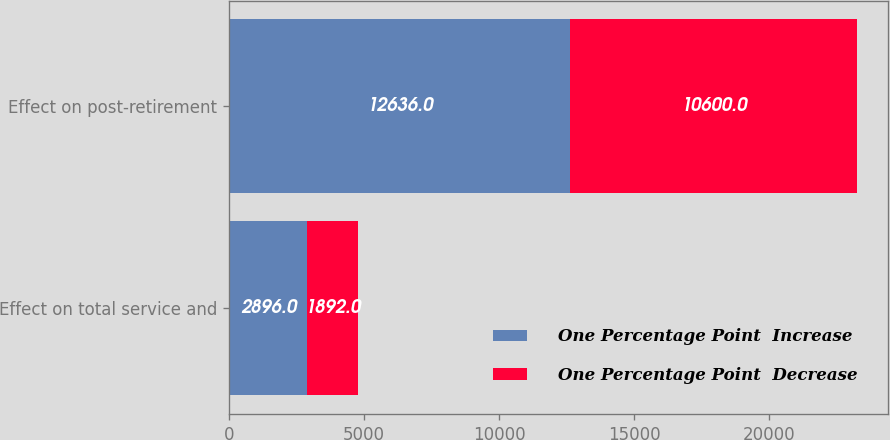Convert chart. <chart><loc_0><loc_0><loc_500><loc_500><stacked_bar_chart><ecel><fcel>Effect on total service and<fcel>Effect on post-retirement<nl><fcel>One Percentage Point  Increase<fcel>2896<fcel>12636<nl><fcel>One Percentage Point  Decrease<fcel>1892<fcel>10600<nl></chart> 